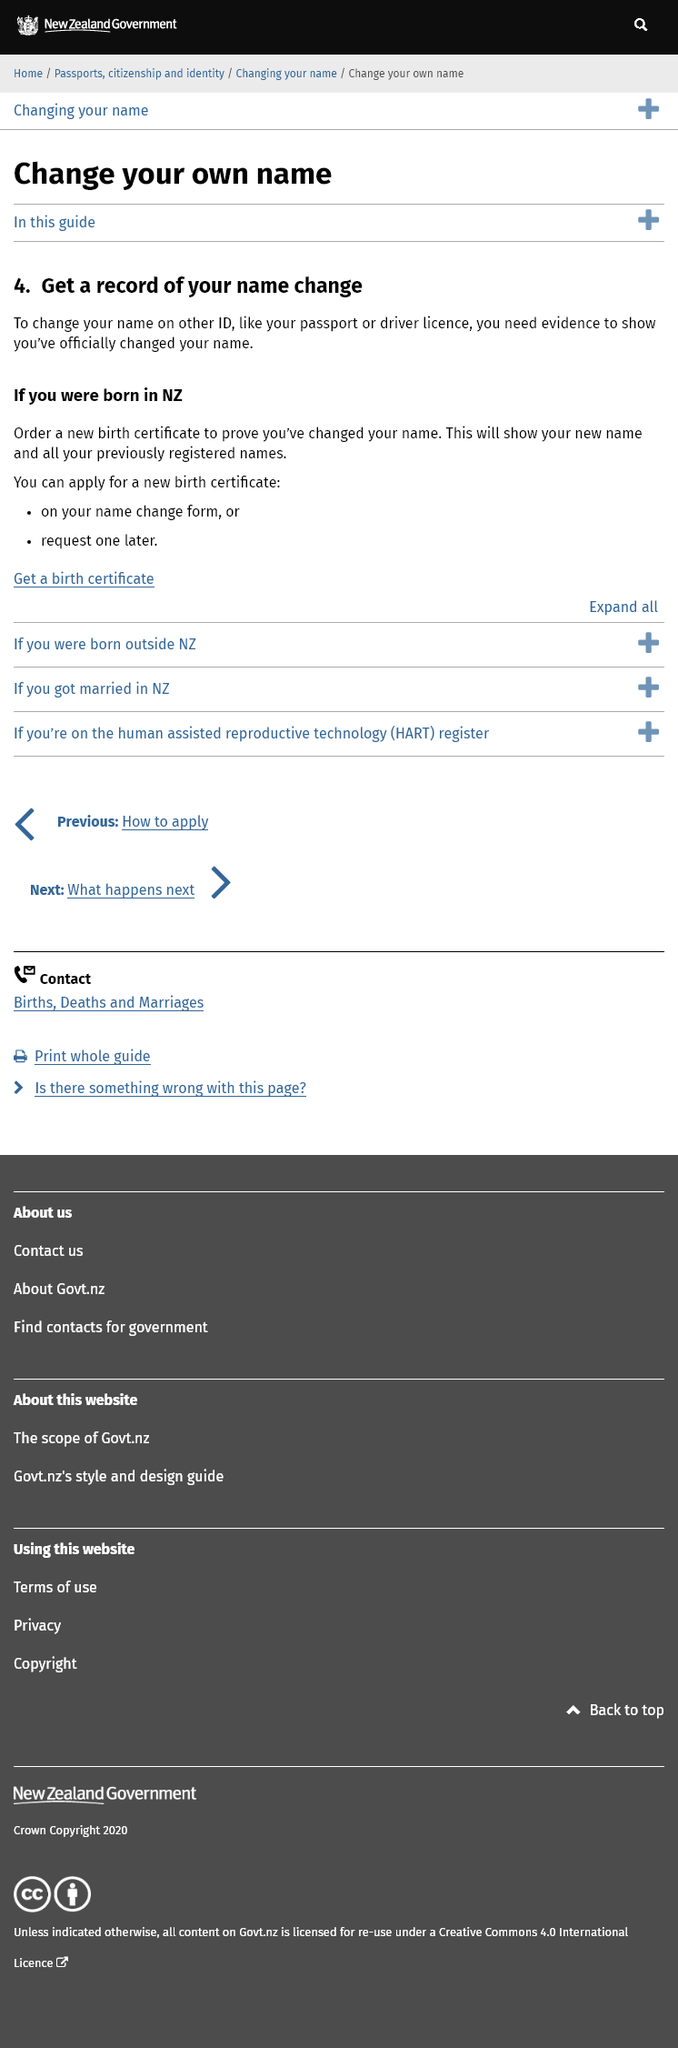Indicate a few pertinent items in this graphic. A new birth certificate in New Zealand will display the names that were previously registered, even if the individual was born after the registration. Yes, you can apply for a new birth certificate on your name change form if you were born in New Zealand. Yes, you need evidence to change your name on a driver's licence. 